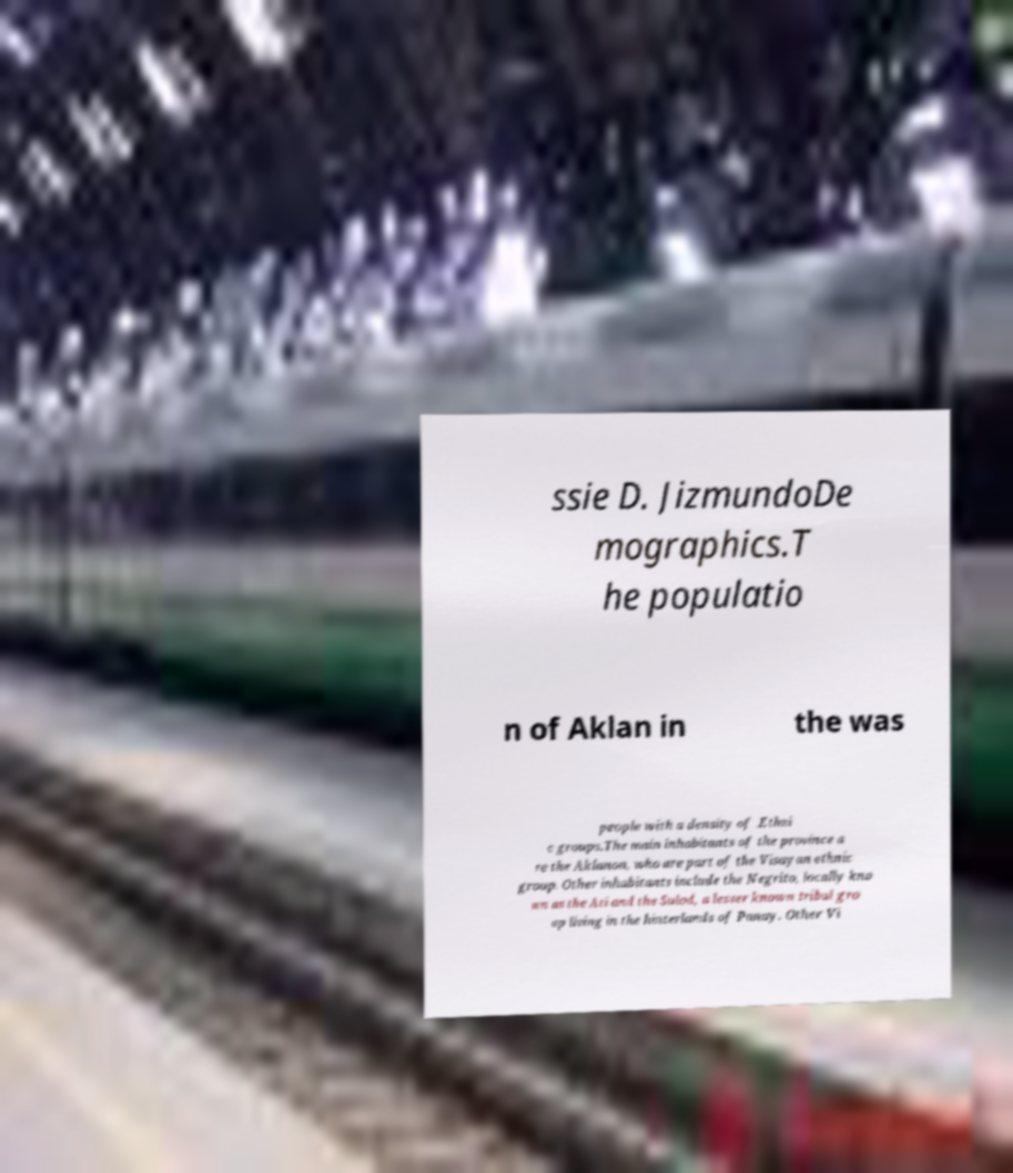I need the written content from this picture converted into text. Can you do that? ssie D. JizmundoDe mographics.T he populatio n of Aklan in the was people with a density of .Ethni c groups.The main inhabitants of the province a re the Aklanon, who are part of the Visayan ethnic group. Other inhabitants include the Negrito, locally kno wn as the Ati and the Sulod, a lesser known tribal gro up living in the hinterlands of Panay. Other Vi 